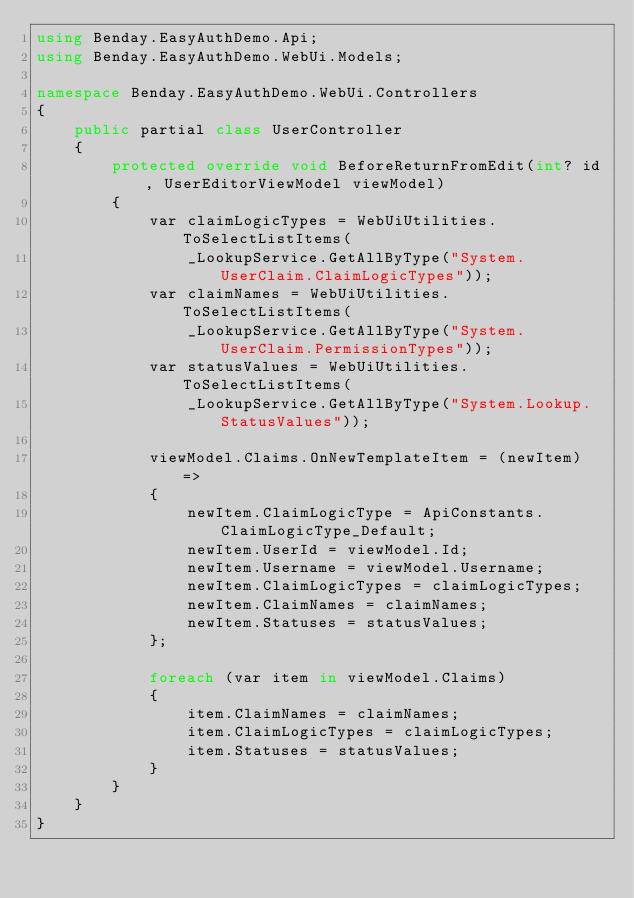<code> <loc_0><loc_0><loc_500><loc_500><_C#_>using Benday.EasyAuthDemo.Api;
using Benday.EasyAuthDemo.WebUi.Models;

namespace Benday.EasyAuthDemo.WebUi.Controllers
{
    public partial class UserController
    {
        protected override void BeforeReturnFromEdit(int? id, UserEditorViewModel viewModel)
        {
            var claimLogicTypes = WebUiUtilities.ToSelectListItems(
                _LookupService.GetAllByType("System.UserClaim.ClaimLogicTypes"));
            var claimNames = WebUiUtilities.ToSelectListItems(
                _LookupService.GetAllByType("System.UserClaim.PermissionTypes"));
            var statusValues = WebUiUtilities.ToSelectListItems(
                _LookupService.GetAllByType("System.Lookup.StatusValues"));

            viewModel.Claims.OnNewTemplateItem = (newItem) =>
            {
                newItem.ClaimLogicType = ApiConstants.ClaimLogicType_Default;
                newItem.UserId = viewModel.Id;
                newItem.Username = viewModel.Username;
                newItem.ClaimLogicTypes = claimLogicTypes;
                newItem.ClaimNames = claimNames;
                newItem.Statuses = statusValues;
            };

            foreach (var item in viewModel.Claims)
            {
                item.ClaimNames = claimNames;
                item.ClaimLogicTypes = claimLogicTypes;
                item.Statuses = statusValues;
            }
        }
    }
}</code> 